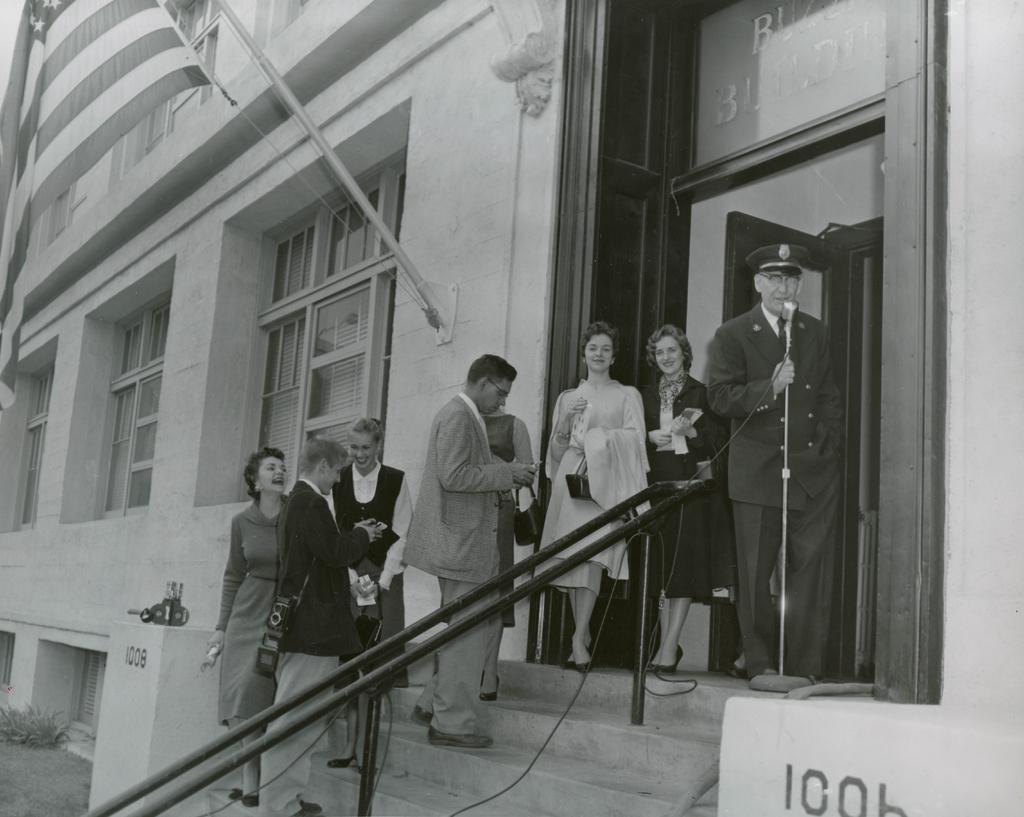Can you describe this image briefly? In this picture we can see some people are standing on stairs, a man on the right side is holding a microphone, in the background there is a building, we can see windows of the building, at the left bottom there is a plant, it is a black and white image. 